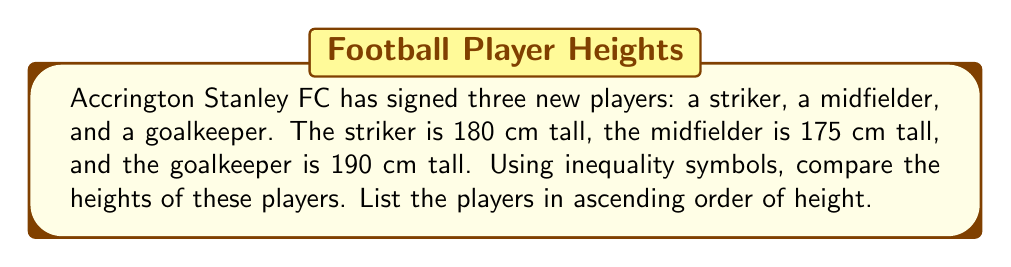Could you help me with this problem? Let's approach this step-by-step:

1. We have three heights to compare:
   Striker: 180 cm
   Midfielder: 175 cm
   Goalkeeper: 190 cm

2. To list them in ascending order, we need to determine which height is the smallest, which is in the middle, and which is the largest.

3. Comparing the heights:
   175 cm < 180 cm < 190 cm

4. This translates to:
   Midfielder < Striker < Goalkeeper

5. Using inequality symbols, we can write this as:
   $\text{Midfielder} < \text{Striker} < \text{Goalkeeper}$

6. Therefore, the ascending order of heights is:
   Midfielder (175 cm), Striker (180 cm), Goalkeeper (190 cm)
Answer: $\text{Midfielder} < \text{Striker} < \text{Goalkeeper}$ 